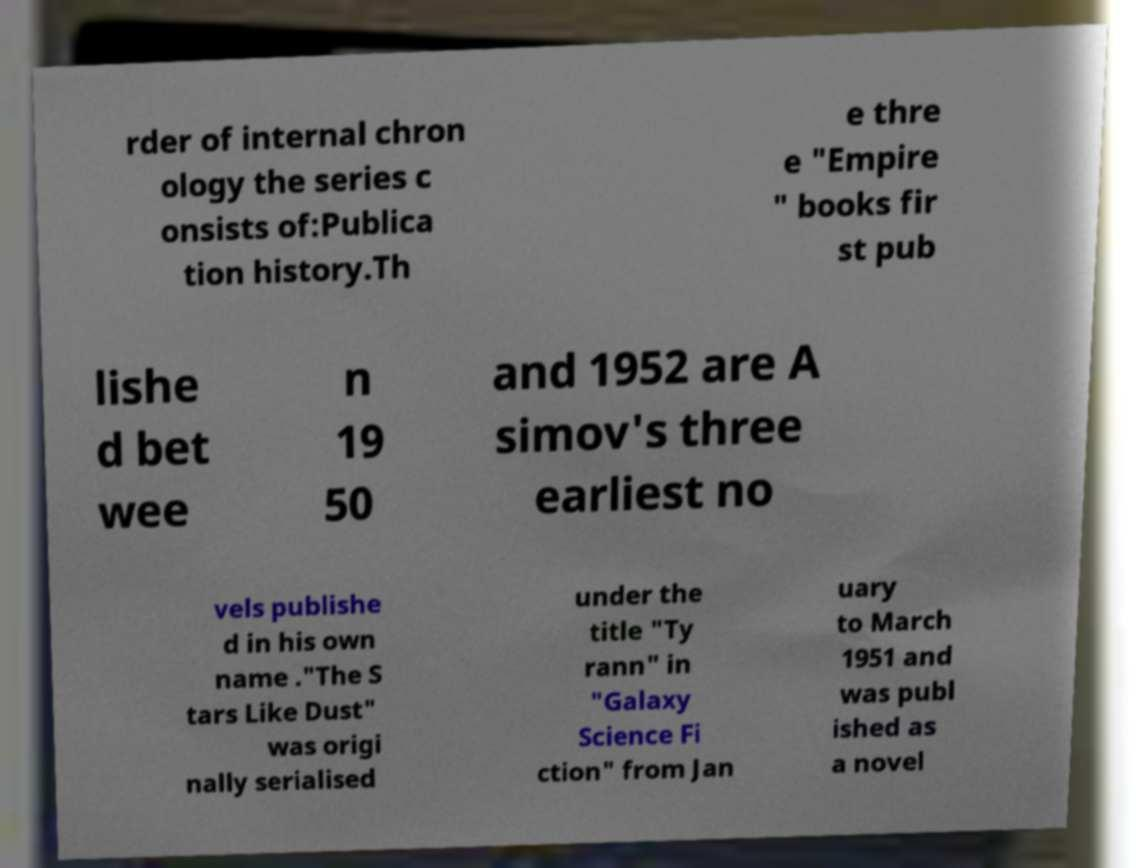Could you assist in decoding the text presented in this image and type it out clearly? rder of internal chron ology the series c onsists of:Publica tion history.Th e thre e "Empire " books fir st pub lishe d bet wee n 19 50 and 1952 are A simov's three earliest no vels publishe d in his own name ."The S tars Like Dust" was origi nally serialised under the title "Ty rann" in "Galaxy Science Fi ction" from Jan uary to March 1951 and was publ ished as a novel 